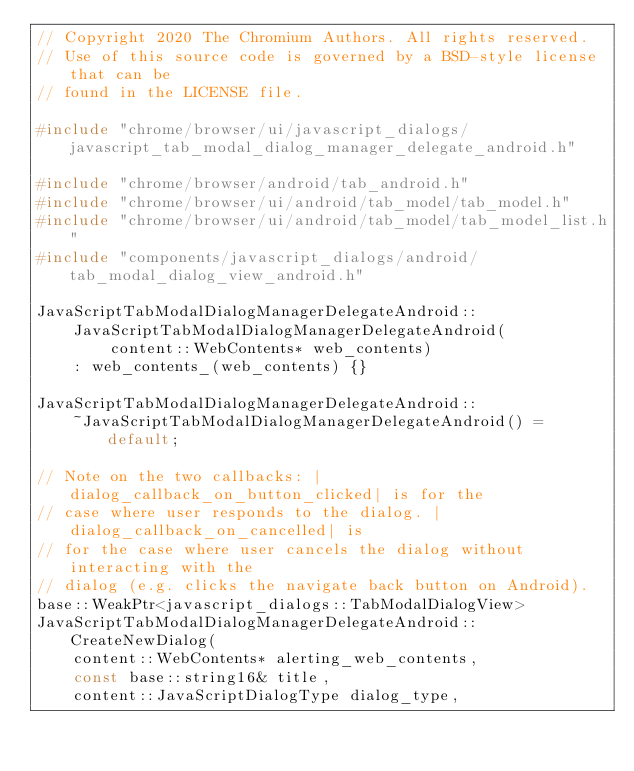<code> <loc_0><loc_0><loc_500><loc_500><_C++_>// Copyright 2020 The Chromium Authors. All rights reserved.
// Use of this source code is governed by a BSD-style license that can be
// found in the LICENSE file.

#include "chrome/browser/ui/javascript_dialogs/javascript_tab_modal_dialog_manager_delegate_android.h"

#include "chrome/browser/android/tab_android.h"
#include "chrome/browser/ui/android/tab_model/tab_model.h"
#include "chrome/browser/ui/android/tab_model/tab_model_list.h"
#include "components/javascript_dialogs/android/tab_modal_dialog_view_android.h"

JavaScriptTabModalDialogManagerDelegateAndroid::
    JavaScriptTabModalDialogManagerDelegateAndroid(
        content::WebContents* web_contents)
    : web_contents_(web_contents) {}

JavaScriptTabModalDialogManagerDelegateAndroid::
    ~JavaScriptTabModalDialogManagerDelegateAndroid() = default;

// Note on the two callbacks: |dialog_callback_on_button_clicked| is for the
// case where user responds to the dialog. |dialog_callback_on_cancelled| is
// for the case where user cancels the dialog without interacting with the
// dialog (e.g. clicks the navigate back button on Android).
base::WeakPtr<javascript_dialogs::TabModalDialogView>
JavaScriptTabModalDialogManagerDelegateAndroid::CreateNewDialog(
    content::WebContents* alerting_web_contents,
    const base::string16& title,
    content::JavaScriptDialogType dialog_type,</code> 